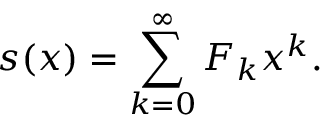Convert formula to latex. <formula><loc_0><loc_0><loc_500><loc_500>s ( x ) = \sum _ { k = 0 } ^ { \infty } F _ { k } x ^ { k } .</formula> 